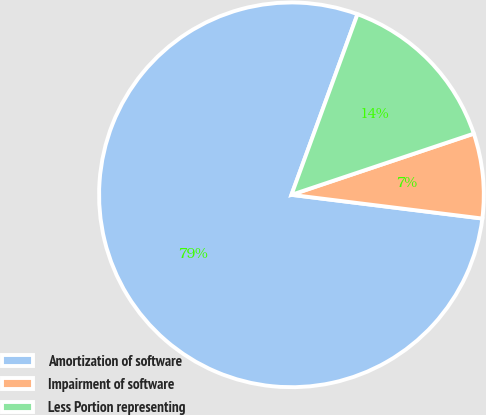<chart> <loc_0><loc_0><loc_500><loc_500><pie_chart><fcel>Amortization of software<fcel>Impairment of software<fcel>Less Portion representing<nl><fcel>78.62%<fcel>7.12%<fcel>14.27%<nl></chart> 